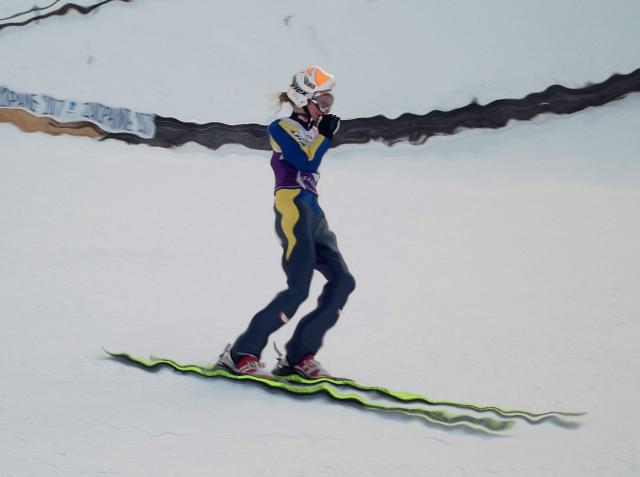What can we infer about the person's skill level in snowboarding from this image? Given the confident pose and the control implied by the body language, it's likely that the person is experienced or at least proficient in snowboarding. Their attire, including a helmet and appropriate gear, also suggests a level of seriousness and commitment to the sport. 